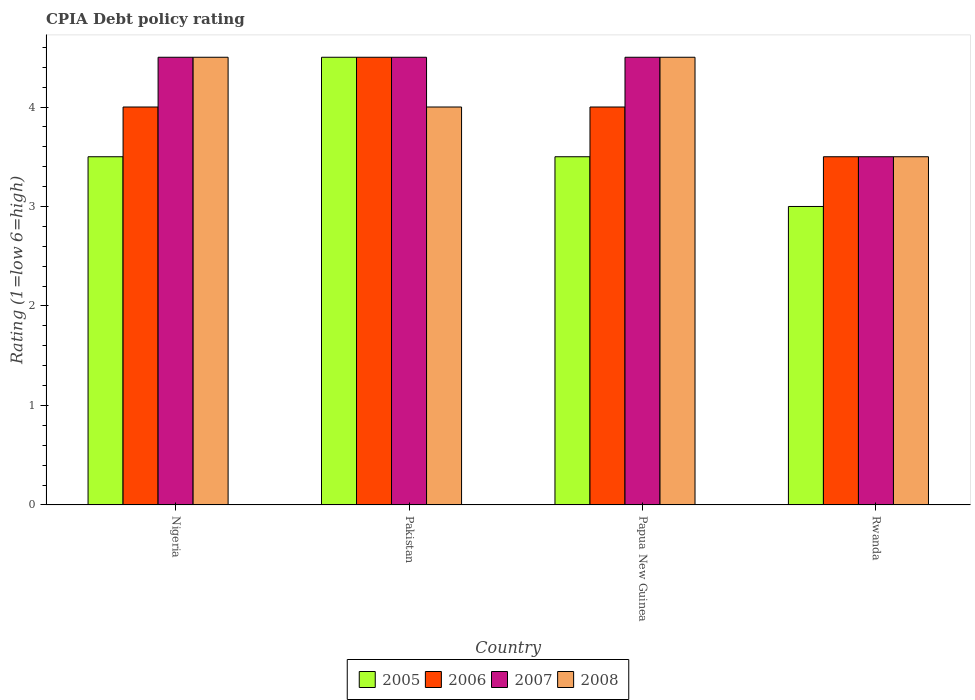How many different coloured bars are there?
Your answer should be compact. 4. Are the number of bars on each tick of the X-axis equal?
Provide a succinct answer. Yes. How many bars are there on the 1st tick from the right?
Provide a short and direct response. 4. What is the label of the 3rd group of bars from the left?
Your answer should be compact. Papua New Guinea. Across all countries, what is the minimum CPIA rating in 2007?
Provide a succinct answer. 3.5. In which country was the CPIA rating in 2008 maximum?
Keep it short and to the point. Nigeria. In which country was the CPIA rating in 2008 minimum?
Your response must be concise. Rwanda. What is the total CPIA rating in 2006 in the graph?
Keep it short and to the point. 16. What is the average CPIA rating in 2008 per country?
Ensure brevity in your answer.  4.12. What is the difference between the CPIA rating of/in 2007 and CPIA rating of/in 2006 in Rwanda?
Ensure brevity in your answer.  0. What is the ratio of the CPIA rating in 2006 in Pakistan to that in Rwanda?
Your answer should be compact. 1.29. Is the CPIA rating in 2007 in Nigeria less than that in Pakistan?
Your answer should be compact. No. Is the difference between the CPIA rating in 2007 in Pakistan and Papua New Guinea greater than the difference between the CPIA rating in 2006 in Pakistan and Papua New Guinea?
Your answer should be very brief. No. What is the difference between the highest and the lowest CPIA rating in 2006?
Give a very brief answer. 1. Is the sum of the CPIA rating in 2006 in Pakistan and Papua New Guinea greater than the maximum CPIA rating in 2008 across all countries?
Your answer should be compact. Yes. What does the 2nd bar from the left in Pakistan represents?
Keep it short and to the point. 2006. Is it the case that in every country, the sum of the CPIA rating in 2007 and CPIA rating in 2005 is greater than the CPIA rating in 2008?
Provide a succinct answer. Yes. How many bars are there?
Your response must be concise. 16. How many countries are there in the graph?
Offer a terse response. 4. Are the values on the major ticks of Y-axis written in scientific E-notation?
Offer a very short reply. No. Does the graph contain grids?
Offer a very short reply. No. Where does the legend appear in the graph?
Your response must be concise. Bottom center. How many legend labels are there?
Your answer should be very brief. 4. How are the legend labels stacked?
Provide a short and direct response. Horizontal. What is the title of the graph?
Give a very brief answer. CPIA Debt policy rating. Does "1971" appear as one of the legend labels in the graph?
Keep it short and to the point. No. What is the Rating (1=low 6=high) of 2006 in Nigeria?
Give a very brief answer. 4. What is the Rating (1=low 6=high) in 2005 in Pakistan?
Your answer should be very brief. 4.5. What is the Rating (1=low 6=high) in 2006 in Pakistan?
Your answer should be compact. 4.5. What is the Rating (1=low 6=high) in 2007 in Pakistan?
Your answer should be compact. 4.5. What is the Rating (1=low 6=high) in 2005 in Papua New Guinea?
Provide a short and direct response. 3.5. What is the Rating (1=low 6=high) of 2006 in Rwanda?
Provide a succinct answer. 3.5. What is the Rating (1=low 6=high) in 2008 in Rwanda?
Offer a terse response. 3.5. Across all countries, what is the maximum Rating (1=low 6=high) in 2005?
Make the answer very short. 4.5. Across all countries, what is the maximum Rating (1=low 6=high) in 2006?
Provide a short and direct response. 4.5. Across all countries, what is the maximum Rating (1=low 6=high) of 2007?
Your response must be concise. 4.5. Across all countries, what is the maximum Rating (1=low 6=high) in 2008?
Provide a succinct answer. 4.5. Across all countries, what is the minimum Rating (1=low 6=high) of 2005?
Your answer should be very brief. 3. What is the total Rating (1=low 6=high) of 2006 in the graph?
Offer a terse response. 16. What is the total Rating (1=low 6=high) in 2008 in the graph?
Offer a terse response. 16.5. What is the difference between the Rating (1=low 6=high) of 2005 in Nigeria and that in Pakistan?
Make the answer very short. -1. What is the difference between the Rating (1=low 6=high) in 2007 in Nigeria and that in Pakistan?
Your response must be concise. 0. What is the difference between the Rating (1=low 6=high) of 2005 in Nigeria and that in Papua New Guinea?
Make the answer very short. 0. What is the difference between the Rating (1=low 6=high) of 2007 in Nigeria and that in Papua New Guinea?
Your answer should be compact. 0. What is the difference between the Rating (1=low 6=high) of 2005 in Nigeria and that in Rwanda?
Provide a succinct answer. 0.5. What is the difference between the Rating (1=low 6=high) in 2006 in Nigeria and that in Rwanda?
Provide a short and direct response. 0.5. What is the difference between the Rating (1=low 6=high) of 2008 in Nigeria and that in Rwanda?
Offer a terse response. 1. What is the difference between the Rating (1=low 6=high) in 2006 in Pakistan and that in Papua New Guinea?
Provide a short and direct response. 0.5. What is the difference between the Rating (1=low 6=high) in 2005 in Pakistan and that in Rwanda?
Ensure brevity in your answer.  1.5. What is the difference between the Rating (1=low 6=high) of 2008 in Pakistan and that in Rwanda?
Keep it short and to the point. 0.5. What is the difference between the Rating (1=low 6=high) in 2005 in Papua New Guinea and that in Rwanda?
Keep it short and to the point. 0.5. What is the difference between the Rating (1=low 6=high) of 2006 in Papua New Guinea and that in Rwanda?
Your answer should be very brief. 0.5. What is the difference between the Rating (1=low 6=high) in 2005 in Nigeria and the Rating (1=low 6=high) in 2006 in Pakistan?
Ensure brevity in your answer.  -1. What is the difference between the Rating (1=low 6=high) in 2005 in Nigeria and the Rating (1=low 6=high) in 2008 in Pakistan?
Keep it short and to the point. -0.5. What is the difference between the Rating (1=low 6=high) of 2006 in Nigeria and the Rating (1=low 6=high) of 2007 in Pakistan?
Your answer should be compact. -0.5. What is the difference between the Rating (1=low 6=high) of 2006 in Nigeria and the Rating (1=low 6=high) of 2008 in Pakistan?
Provide a succinct answer. 0. What is the difference between the Rating (1=low 6=high) of 2007 in Nigeria and the Rating (1=low 6=high) of 2008 in Pakistan?
Offer a very short reply. 0.5. What is the difference between the Rating (1=low 6=high) of 2005 in Nigeria and the Rating (1=low 6=high) of 2006 in Papua New Guinea?
Your answer should be very brief. -0.5. What is the difference between the Rating (1=low 6=high) of 2005 in Nigeria and the Rating (1=low 6=high) of 2007 in Papua New Guinea?
Provide a succinct answer. -1. What is the difference between the Rating (1=low 6=high) of 2005 in Nigeria and the Rating (1=low 6=high) of 2008 in Papua New Guinea?
Provide a short and direct response. -1. What is the difference between the Rating (1=low 6=high) in 2006 in Nigeria and the Rating (1=low 6=high) in 2007 in Papua New Guinea?
Provide a short and direct response. -0.5. What is the difference between the Rating (1=low 6=high) in 2006 in Nigeria and the Rating (1=low 6=high) in 2008 in Papua New Guinea?
Make the answer very short. -0.5. What is the difference between the Rating (1=low 6=high) in 2007 in Nigeria and the Rating (1=low 6=high) in 2008 in Papua New Guinea?
Offer a very short reply. 0. What is the difference between the Rating (1=low 6=high) of 2006 in Nigeria and the Rating (1=low 6=high) of 2007 in Rwanda?
Give a very brief answer. 0.5. What is the difference between the Rating (1=low 6=high) of 2007 in Nigeria and the Rating (1=low 6=high) of 2008 in Rwanda?
Your answer should be compact. 1. What is the difference between the Rating (1=low 6=high) in 2005 in Pakistan and the Rating (1=low 6=high) in 2006 in Papua New Guinea?
Your response must be concise. 0.5. What is the difference between the Rating (1=low 6=high) of 2005 in Pakistan and the Rating (1=low 6=high) of 2008 in Papua New Guinea?
Give a very brief answer. 0. What is the difference between the Rating (1=low 6=high) in 2006 in Pakistan and the Rating (1=low 6=high) in 2008 in Papua New Guinea?
Your response must be concise. 0. What is the difference between the Rating (1=low 6=high) of 2005 in Pakistan and the Rating (1=low 6=high) of 2007 in Rwanda?
Your response must be concise. 1. What is the difference between the Rating (1=low 6=high) of 2005 in Papua New Guinea and the Rating (1=low 6=high) of 2008 in Rwanda?
Give a very brief answer. 0. What is the difference between the Rating (1=low 6=high) of 2006 in Papua New Guinea and the Rating (1=low 6=high) of 2007 in Rwanda?
Offer a terse response. 0.5. What is the difference between the Rating (1=low 6=high) in 2006 in Papua New Guinea and the Rating (1=low 6=high) in 2008 in Rwanda?
Keep it short and to the point. 0.5. What is the average Rating (1=low 6=high) of 2005 per country?
Your response must be concise. 3.62. What is the average Rating (1=low 6=high) of 2006 per country?
Offer a very short reply. 4. What is the average Rating (1=low 6=high) in 2007 per country?
Make the answer very short. 4.25. What is the average Rating (1=low 6=high) in 2008 per country?
Offer a very short reply. 4.12. What is the difference between the Rating (1=low 6=high) of 2005 and Rating (1=low 6=high) of 2007 in Nigeria?
Make the answer very short. -1. What is the difference between the Rating (1=low 6=high) of 2006 and Rating (1=low 6=high) of 2008 in Nigeria?
Provide a succinct answer. -0.5. What is the difference between the Rating (1=low 6=high) of 2006 and Rating (1=low 6=high) of 2008 in Pakistan?
Your response must be concise. 0.5. What is the difference between the Rating (1=low 6=high) of 2005 and Rating (1=low 6=high) of 2006 in Papua New Guinea?
Your answer should be very brief. -0.5. What is the difference between the Rating (1=low 6=high) in 2005 and Rating (1=low 6=high) in 2007 in Papua New Guinea?
Provide a succinct answer. -1. What is the difference between the Rating (1=low 6=high) of 2005 and Rating (1=low 6=high) of 2008 in Papua New Guinea?
Your answer should be compact. -1. What is the difference between the Rating (1=low 6=high) in 2006 and Rating (1=low 6=high) in 2007 in Papua New Guinea?
Provide a succinct answer. -0.5. What is the difference between the Rating (1=low 6=high) of 2006 and Rating (1=low 6=high) of 2008 in Papua New Guinea?
Ensure brevity in your answer.  -0.5. What is the difference between the Rating (1=low 6=high) in 2006 and Rating (1=low 6=high) in 2007 in Rwanda?
Ensure brevity in your answer.  0. What is the difference between the Rating (1=low 6=high) in 2006 and Rating (1=low 6=high) in 2008 in Rwanda?
Provide a succinct answer. 0. What is the ratio of the Rating (1=low 6=high) in 2005 in Nigeria to that in Pakistan?
Your answer should be compact. 0.78. What is the ratio of the Rating (1=low 6=high) in 2006 in Nigeria to that in Pakistan?
Provide a short and direct response. 0.89. What is the ratio of the Rating (1=low 6=high) of 2007 in Nigeria to that in Pakistan?
Your response must be concise. 1. What is the ratio of the Rating (1=low 6=high) of 2005 in Nigeria to that in Papua New Guinea?
Keep it short and to the point. 1. What is the ratio of the Rating (1=low 6=high) in 2007 in Nigeria to that in Papua New Guinea?
Your response must be concise. 1. What is the ratio of the Rating (1=low 6=high) in 2008 in Nigeria to that in Papua New Guinea?
Provide a succinct answer. 1. What is the ratio of the Rating (1=low 6=high) of 2005 in Nigeria to that in Rwanda?
Offer a very short reply. 1.17. What is the ratio of the Rating (1=low 6=high) in 2005 in Pakistan to that in Papua New Guinea?
Offer a terse response. 1.29. What is the ratio of the Rating (1=low 6=high) of 2006 in Pakistan to that in Papua New Guinea?
Your answer should be very brief. 1.12. What is the ratio of the Rating (1=low 6=high) in 2007 in Pakistan to that in Papua New Guinea?
Keep it short and to the point. 1. What is the ratio of the Rating (1=low 6=high) of 2005 in Pakistan to that in Rwanda?
Your answer should be compact. 1.5. What is the ratio of the Rating (1=low 6=high) in 2008 in Pakistan to that in Rwanda?
Ensure brevity in your answer.  1.14. What is the ratio of the Rating (1=low 6=high) of 2005 in Papua New Guinea to that in Rwanda?
Make the answer very short. 1.17. What is the ratio of the Rating (1=low 6=high) in 2008 in Papua New Guinea to that in Rwanda?
Keep it short and to the point. 1.29. What is the difference between the highest and the lowest Rating (1=low 6=high) of 2005?
Provide a short and direct response. 1.5. What is the difference between the highest and the lowest Rating (1=low 6=high) of 2008?
Your answer should be very brief. 1. 